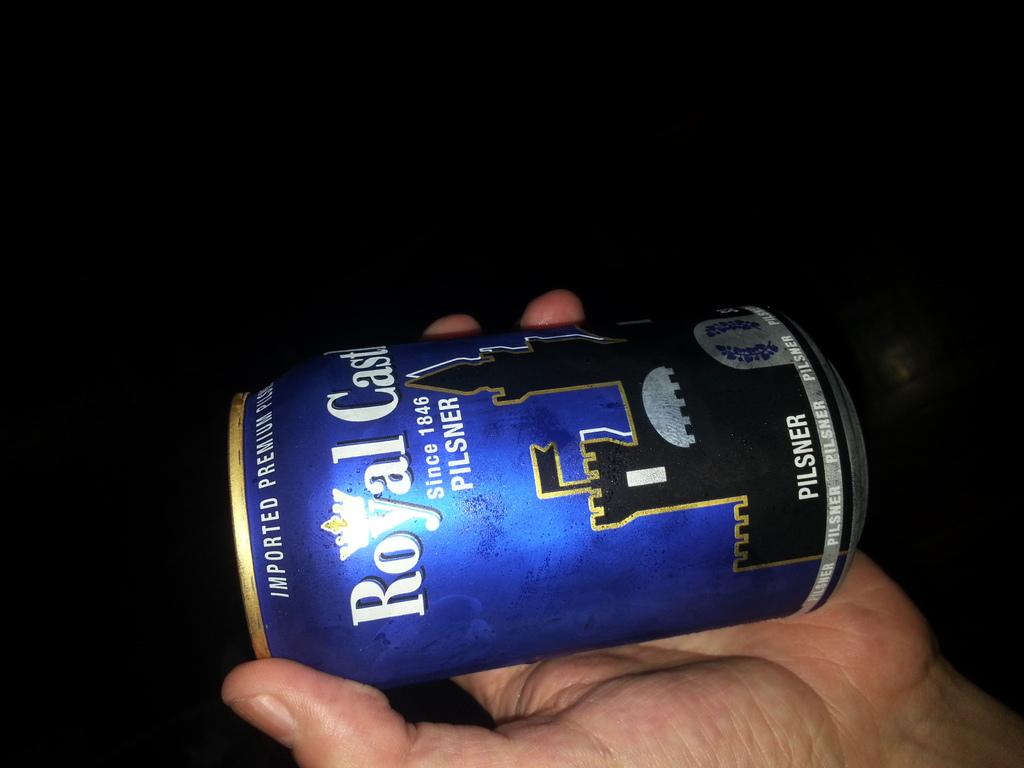How long ago did the type of beverage get distributed?
Make the answer very short. 1846. 